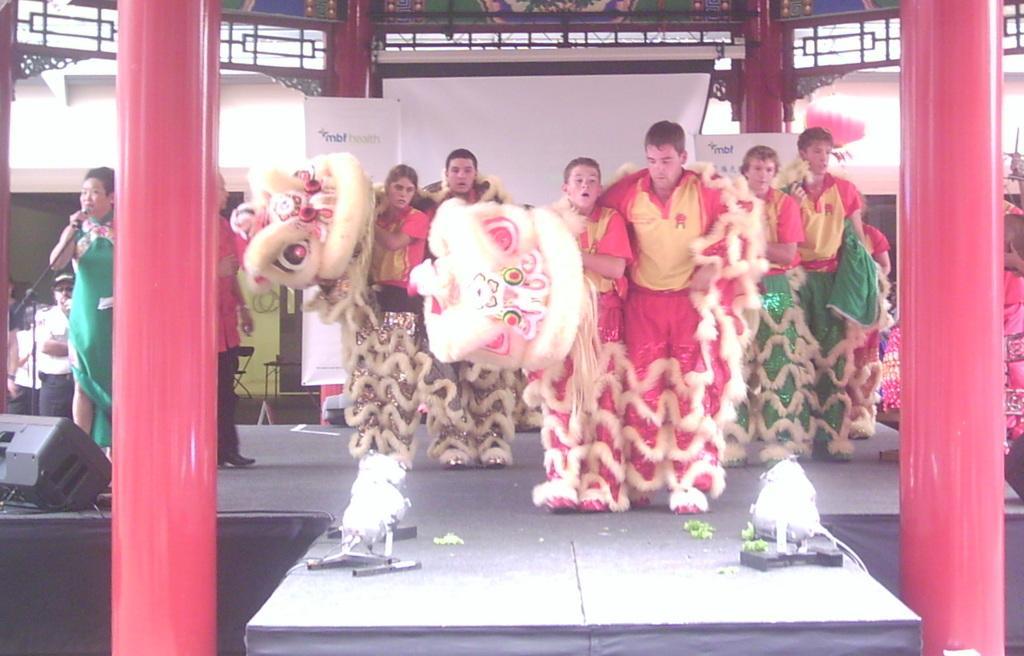Please provide a concise description of this image. People are present on the stage. They are wearing costumes. A person is standing at the left wearing a green dress and there is a microphone. There are light, red pillars, projector display and there are banners at the back. 